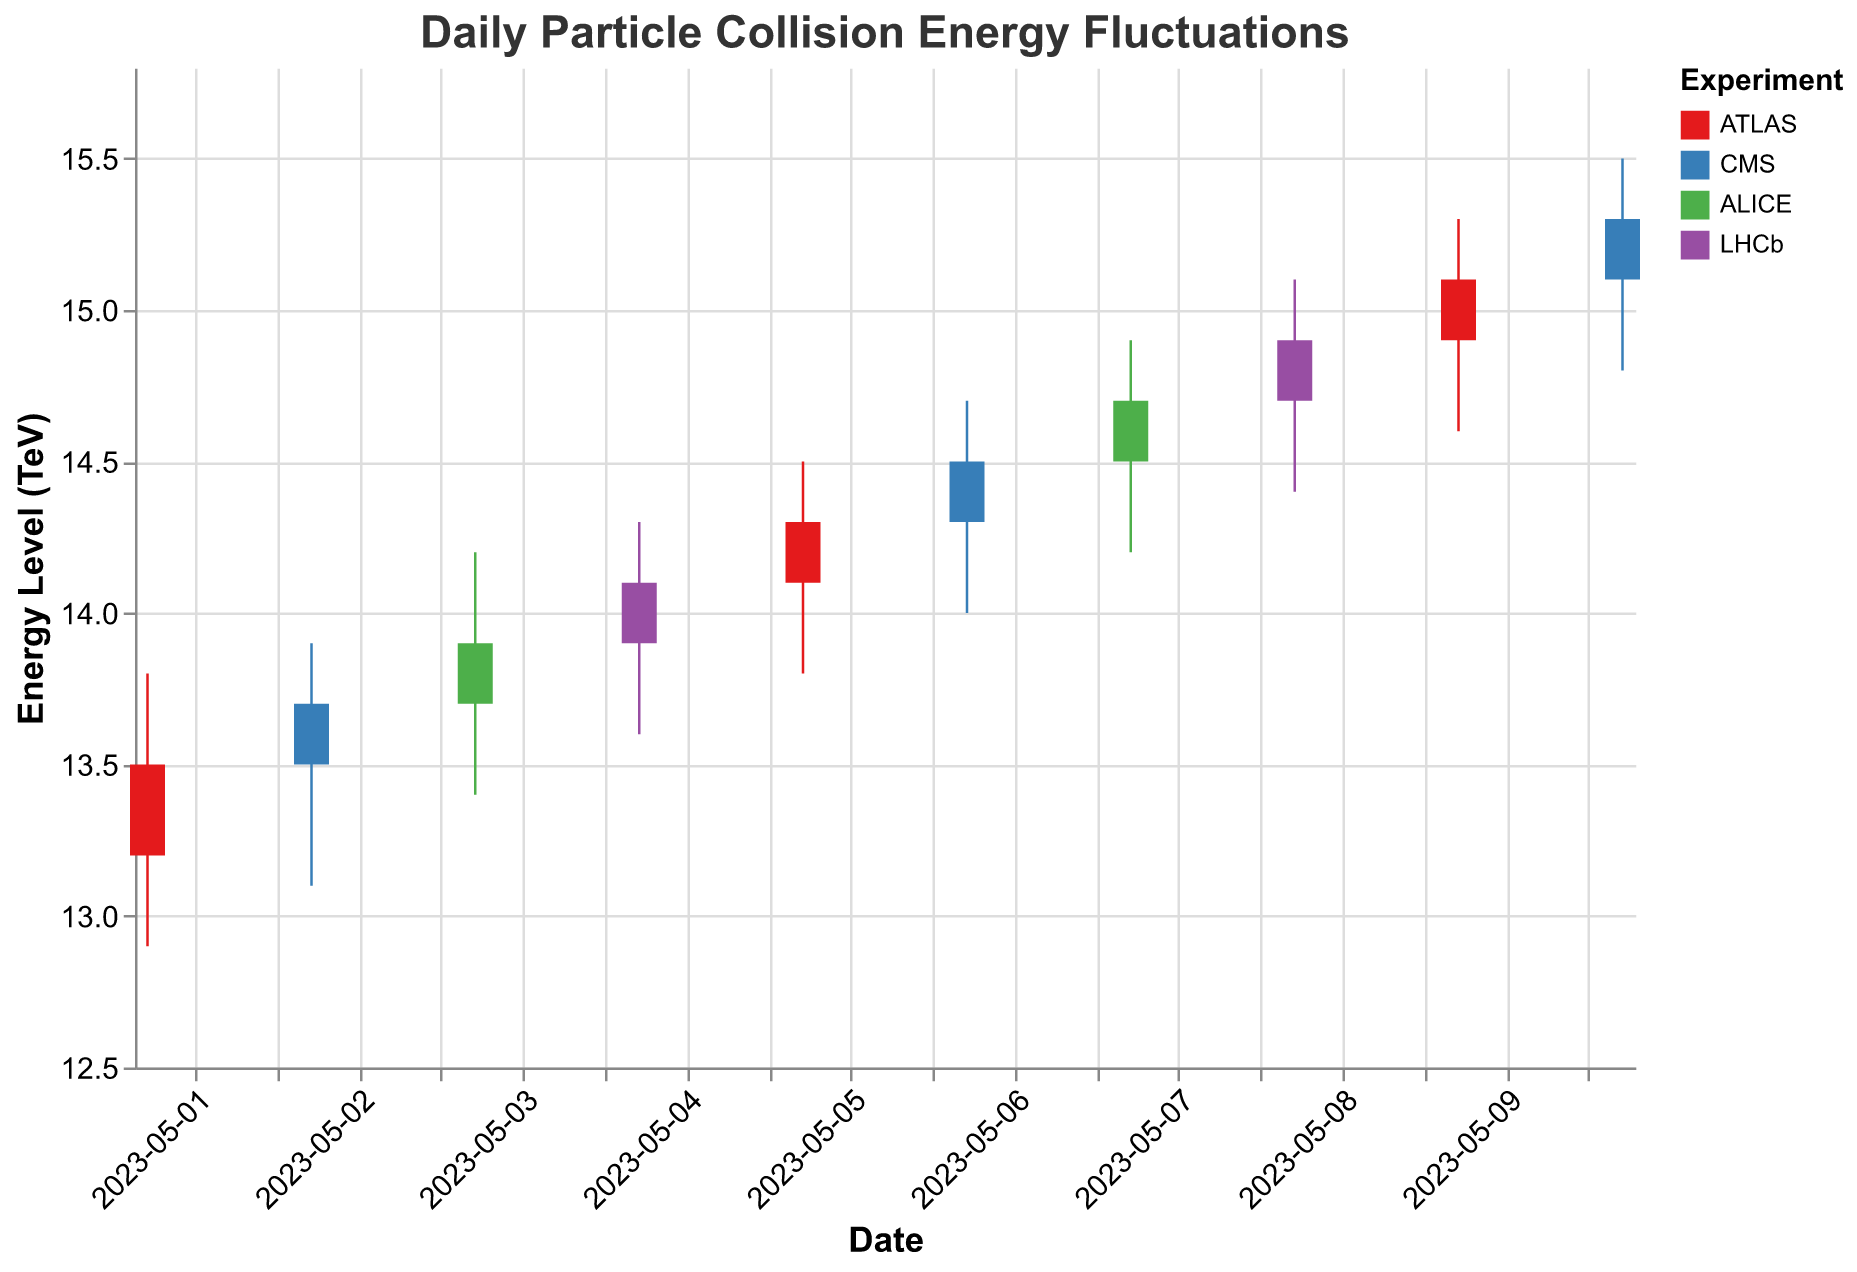What is the title of the figure? The title of the figure is written at the top, it reads "Daily Particle Collision Energy Fluctuations".
Answer: Daily Particle Collision Energy Fluctuations Which experiment had the highest energy level on 2023-05-05? On 2023-05-05, the experiment with the highest energy level as shown by the "High" value was ATLAS, reaching 14.5 TeV.
Answer: ATLAS How many distinct experiments are represented in the figure? There are four distinct experiments represented by different colors in the chart legend: ATLAS, CMS, ALICE, and LHCb.
Answer: Four Compare the opening energy levels of ATLAS on 2023-05-01 and 2023-05-05. Which day had a higher opening level? On 2023-05-01, ATLAS had an opening level of 13.2 TeV, whereas on 2023-05-05, the opening level was 14.1 TeV. So, 2023-05-05 had a higher opening level.
Answer: 2023-05-05 Which experiment shows a consistent increasing trend in the closing energy levels over the displayed time period? By observing the "Close" values for each experiment, CMS shows a consistent increasing trend: 13.7 on 2023-05-02, 14.5 on 2023-05-06, and 15.3 on 2023-05-10.
Answer: CMS What is the average high energy level recorded by ALICE during this period? First find the high values for ALICE: 14.2 on 2023-05-03 and 14.9 on 2023-05-07. The average is (14.2 + 14.9) / 2 = 14.55 TeV.
Answer: 14.55 Between which two consecutive days did ATLAS experience the largest increase in closing energy levels? Compare the consecutive closing values for ATLAS: 13.5 to 14.3 (2023-05-01 to 2023-05-05) and 14.3 to 15.1 (2023-05-05 to 2023-05-09). The largest increase is between 2023-05-05 to 2023-05-09 (0.8 TeV).
Answer: 2023-05-05 to 2023-05-09 What was the lowest energy level achieved by any experiment and on which date did it occur? The lowest energy level is represented by the "Low" values. The lowest value is 12.9 TeV by ATLAS on 2023-05-01.
Answer: 12.9 TeV on 2023-05-01 Is there any day where the opening and closing energy levels were the same for an experiment? By examining the chart, there is no instance where the "Open" and "Close" values are the same for any experiment on a given day.
Answer: No 